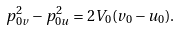<formula> <loc_0><loc_0><loc_500><loc_500>p _ { 0 v } ^ { 2 } - p _ { 0 u } ^ { 2 } = 2 V _ { 0 } ( v _ { 0 } - u _ { 0 } ) .</formula> 